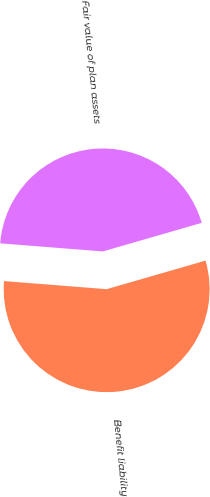<chart> <loc_0><loc_0><loc_500><loc_500><pie_chart><fcel>Benefit liability<fcel>Fair value of plan assets<nl><fcel>55.73%<fcel>44.27%<nl></chart> 